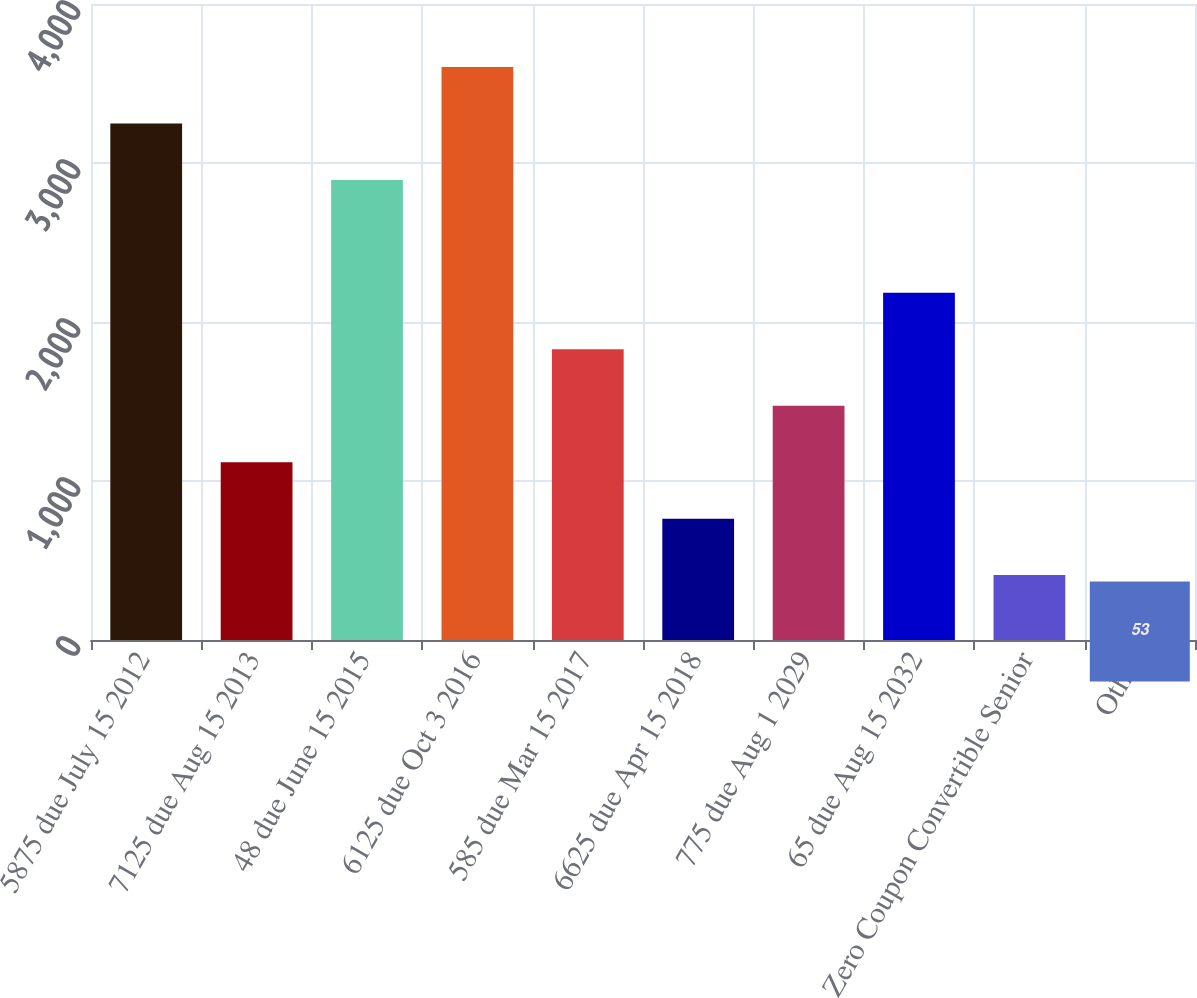Convert chart to OTSL. <chart><loc_0><loc_0><loc_500><loc_500><bar_chart><fcel>5875 due July 15 2012<fcel>7125 due Aug 15 2013<fcel>48 due June 15 2015<fcel>6125 due Oct 3 2016<fcel>585 due Mar 15 2017<fcel>6625 due Apr 15 2018<fcel>775 due Aug 1 2029<fcel>65 due Aug 15 2032<fcel>Zero Coupon Convertible Senior<fcel>Other<nl><fcel>3248.9<fcel>1118.3<fcel>2893.8<fcel>3604<fcel>1828.5<fcel>763.2<fcel>1473.4<fcel>2183.6<fcel>408.1<fcel>53<nl></chart> 